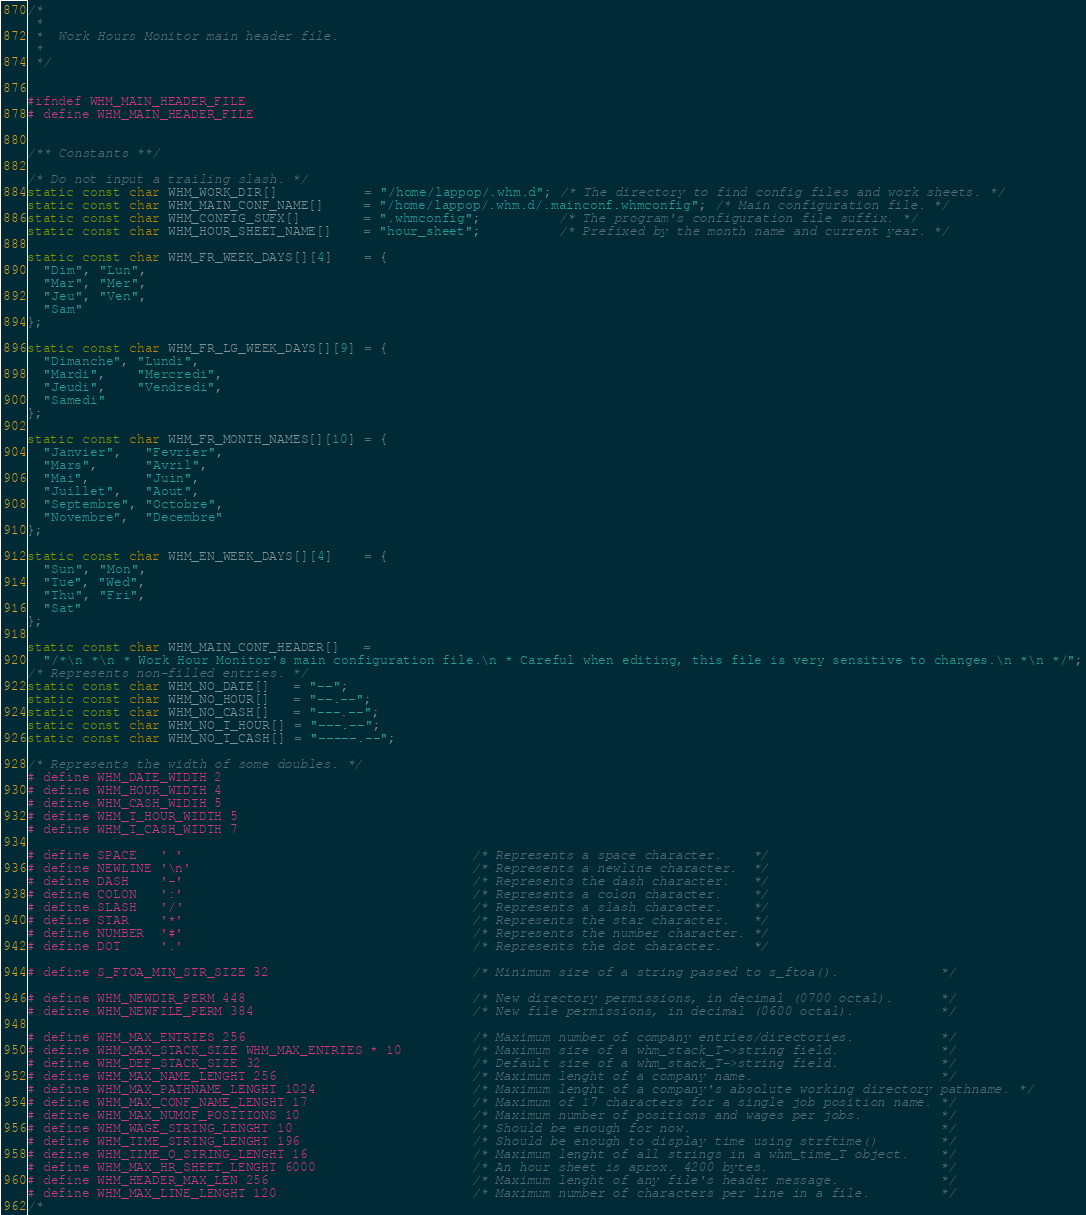Convert code to text. <code><loc_0><loc_0><loc_500><loc_500><_C_>/*
 *
 *  Work Hours Monitor main header file.
 *
 */


#ifndef WHM_MAIN_HEADER_FILE
# define WHM_MAIN_HEADER_FILE


/** Constants **/

/* Do not input a trailing slash. */
static const char WHM_WORK_DIR[]           = "/home/lappop/.whm.d"; /* The directory to find config files and work sheets. */
static const char WHM_MAIN_CONF_NAME[]     = "/home/lappop/.whm.d/.mainconf.whmconfig"; /* Main configuration file. */
static const char WHM_CONFIG_SUFX[]        = ".whmconfig";          /* The program's configuration file suffix. */
static const char WHM_HOUR_SHEET_NAME[]    = "hour_sheet";          /* Prefixed by the month name and current year. */

static const char WHM_FR_WEEK_DAYS[][4]    = {
  "Dim", "Lun",
  "Mar", "Mer",
  "Jeu", "Ven",
  "Sam"
};

static const char WHM_FR_LG_WEEK_DAYS[][9] = {
  "Dimanche", "Lundi",
  "Mardi",    "Mercredi",
  "Jeudi",    "Vendredi",
  "Samedi"
};

static const char WHM_FR_MONTH_NAMES[][10] = {
  "Janvier",   "Fevrier",
  "Mars",      "Avril",
  "Mai",       "Juin",
  "Juillet",   "Aout",
  "Septembre", "Octobre",
  "Novembre",  "Decembre"
};

static const char WHM_EN_WEEK_DAYS[][4]    = {
  "Sun", "Mon",
  "Tue", "Wed",
  "Thu", "Fri",
  "Sat"
};

static const char WHM_MAIN_CONF_HEADER[]   =
  "/*\n *\n * Work Hour Monitor's main configuration file.\n * Careful when editing, this file is very sensitive to changes.\n *\n */";
/* Represents non-filled entries. */
static const char WHM_NO_DATE[]   = "--";
static const char WHM_NO_HOUR[]   = "--.--";
static const char WHM_NO_CASH[]   = "---.--";
static const char WHM_NO_T_HOUR[] = "---.--";
static const char WHM_NO_T_CASH[] = "-----.--";

/* Represents the width of some doubles. */
# define WHM_DATE_WIDTH 2
# define WHM_HOUR_WIDTH 4
# define WHM_CASH_WIDTH 5
# define WHM_T_HOUR_WIDTH 5
# define WHM_T_CASH_WIDTH 7

# define SPACE   ' '                                     /* Represents a space character.    */
# define NEWLINE '\n'                                    /* Represents a newline character.  */
# define DASH    '-'                                     /* Represents the dash character.   */
# define COLON   ':'                                     /* Represents a colon character.    */
# define SLASH   '/'                                     /* Represents a slash character.    */
# define STAR    '*'                                     /* Represents the star character.   */
# define NUMBER  '#'                                     /* Represents the number character. */
# define DOT     '.'                                     /* Represents the dot character.    */

# define S_FTOA_MIN_STR_SIZE 32                          /* Minimum size of a string passed to s_ftoa().             */

# define WHM_NEWDIR_PERM 448                             /* New directory permissions, in decimal (0700 octal).      */
# define WHM_NEWFILE_PERM 384                            /* New file permissions, in decimal (0600 octal).           */

# define WHM_MAX_ENTRIES 256                             /* Maximum number of company entries/directories.           */
# define WHM_MAX_STACK_SIZE WHM_MAX_ENTRIES * 10         /* Maximum size of a whm_stack_T->string field.             */
# define WHM_DEF_STACK_SIZE 32                           /* Default size of a whm_stack_T->string field.             */
# define WHM_MAX_NAME_LENGHT 256                         /* Maximum lenght of a company name.                        */
# define WHM_MAX_PATHNAME_LENGHT 1024                    /* Maximum lenght of a company's absolute working directory pathname. */
# define WHM_MAX_CONF_NAME_LENGHT 17                     /* Maximum of 17 characters for a single job position name. */
# define WHM_MAX_NUMOF_POSITIONS 10                      /* Maximum number of positions and wages per jobs.          */
# define WHM_WAGE_STRING_LENGHT 10                       /* Should be enough for now.                                */
# define WHM_TIME_STRING_LENGHT 196                      /* Should be enough to display time using strftime()        */
# define WHM_TIME_O_STRING_LENGHT 16                     /* Maximum lenght of all strings in a whm_time_T object.    */
# define WHM_MAX_HR_SHEET_LENGHT 6000                    /* An hour sheet is aprox. 4200 bytes.                      */
# define WHM_HEADER_MAX_LEN 256                          /* Maximum lenght of any file's header message.             */
# define WHM_MAX_LINE_LENGHT 120                         /* Maximum number of characters per line in a file.         */
/* </code> 